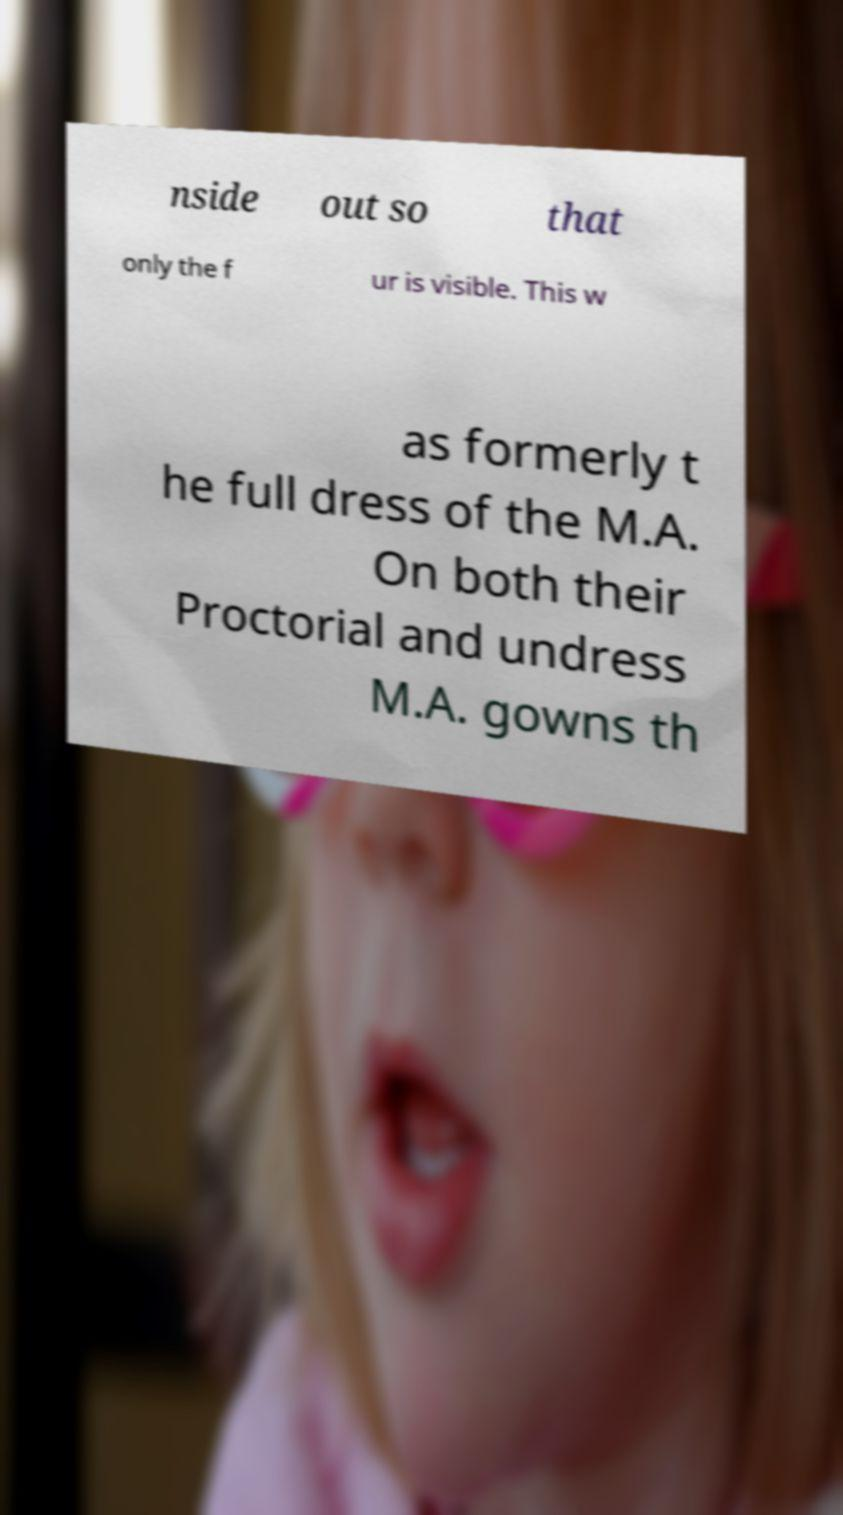Could you assist in decoding the text presented in this image and type it out clearly? nside out so that only the f ur is visible. This w as formerly t he full dress of the M.A. On both their Proctorial and undress M.A. gowns th 